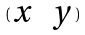<formula> <loc_0><loc_0><loc_500><loc_500>( \begin{matrix} x & y \end{matrix} )</formula> 